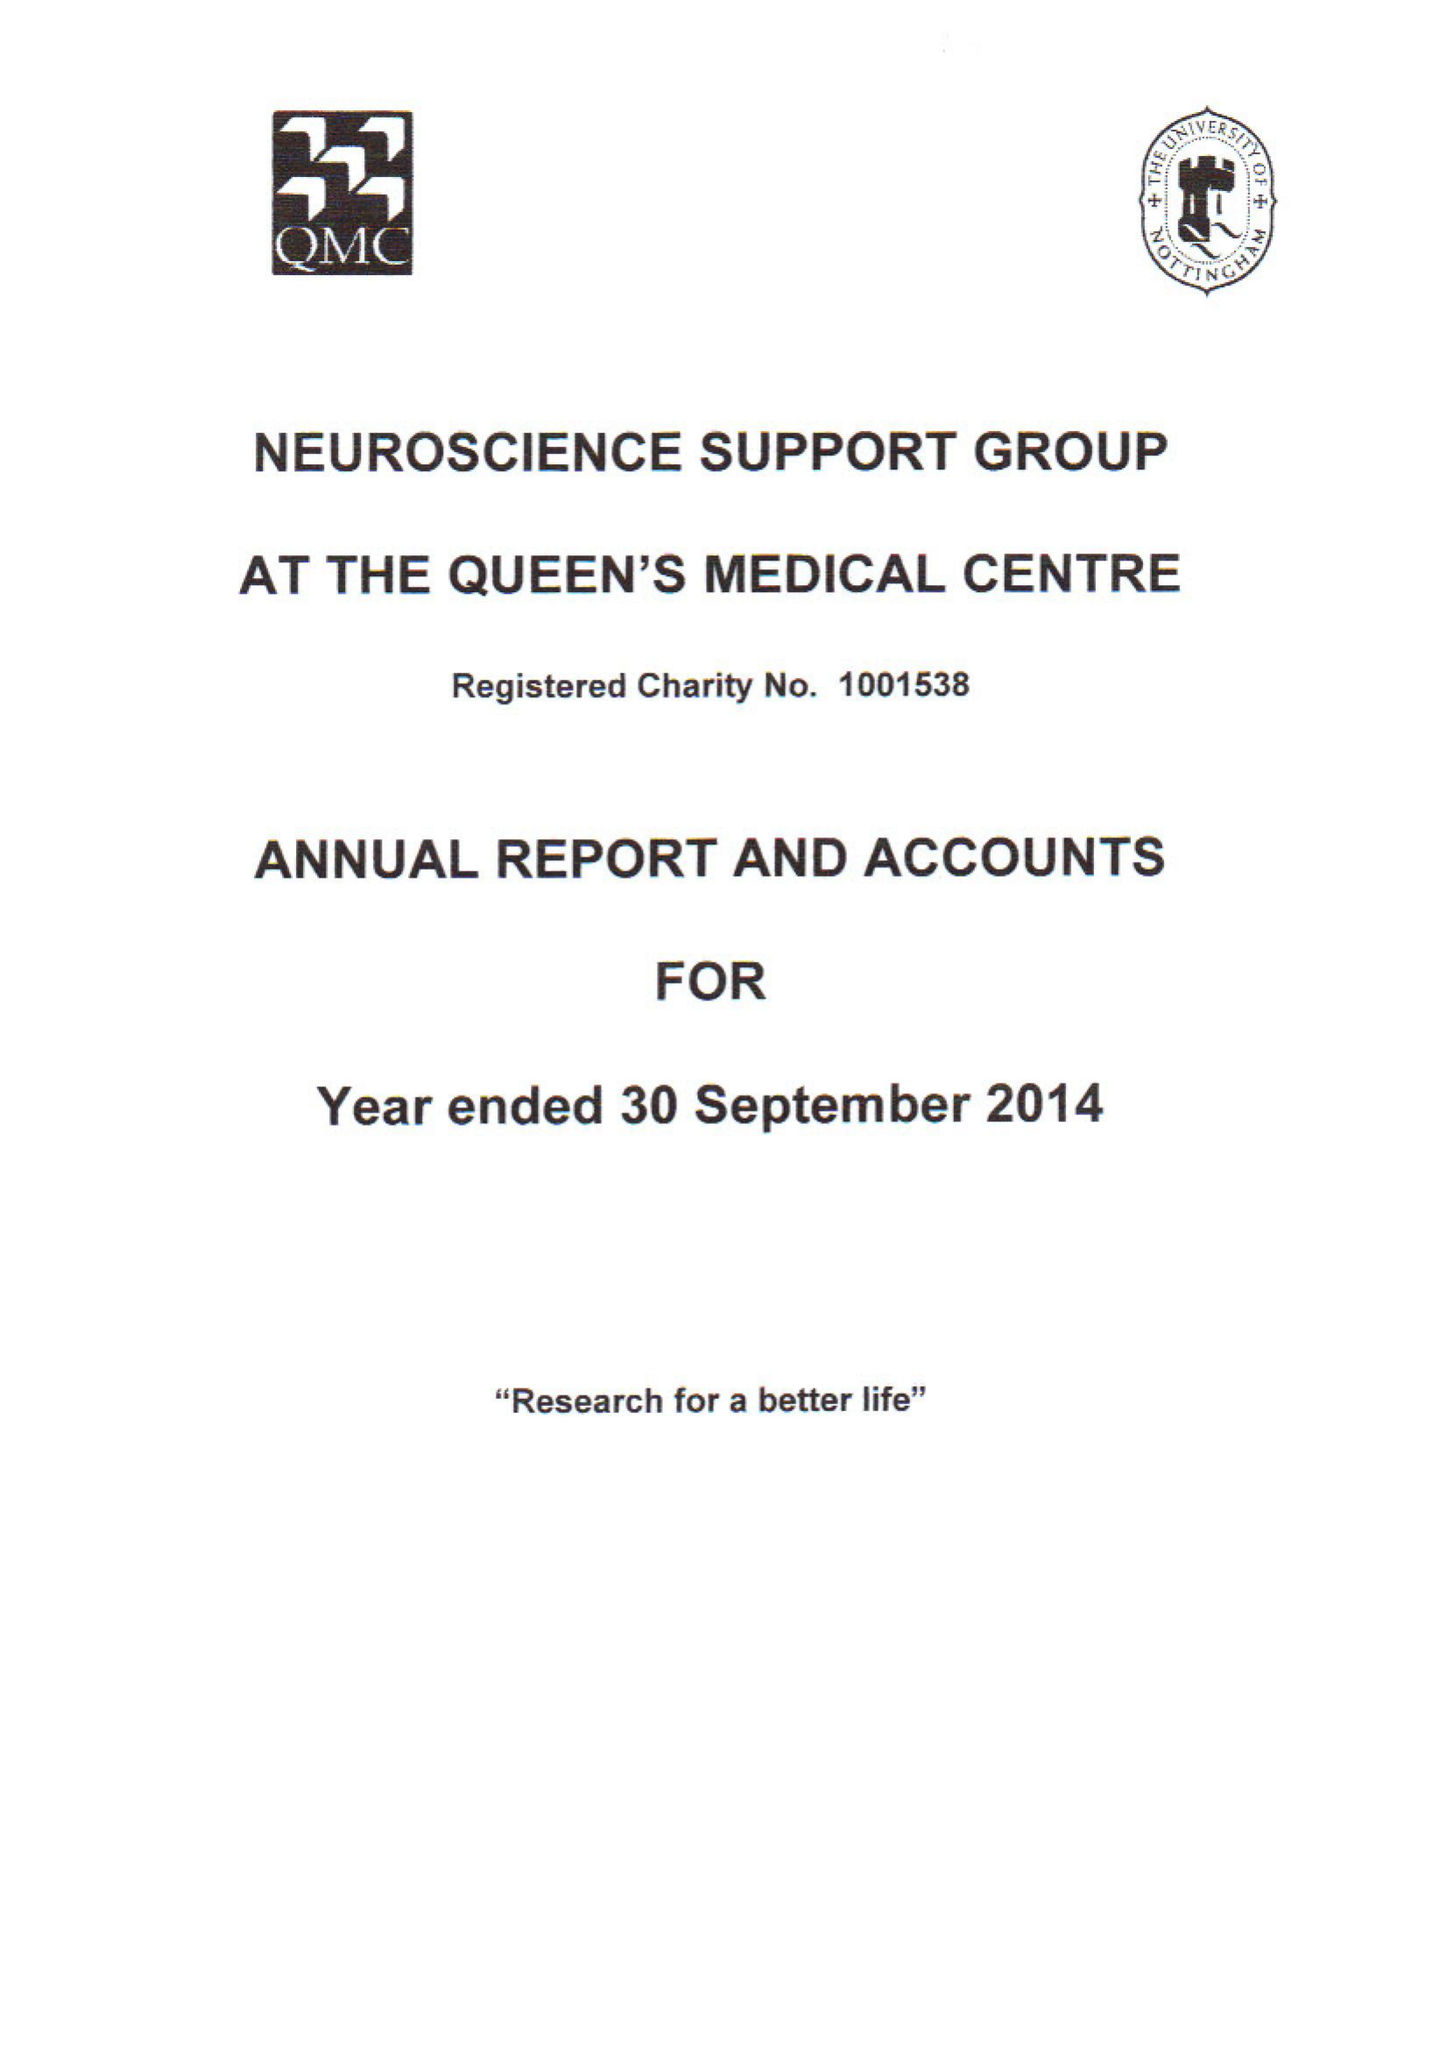What is the value for the charity_number?
Answer the question using a single word or phrase. 1001538 